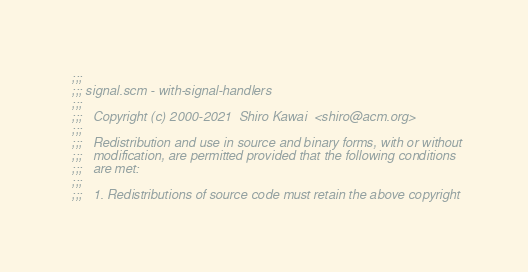<code> <loc_0><loc_0><loc_500><loc_500><_Scheme_>;;;
;;; signal.scm - with-signal-handlers
;;;
;;;   Copyright (c) 2000-2021  Shiro Kawai  <shiro@acm.org>
;;;
;;;   Redistribution and use in source and binary forms, with or without
;;;   modification, are permitted provided that the following conditions
;;;   are met:
;;;
;;;   1. Redistributions of source code must retain the above copyright</code> 